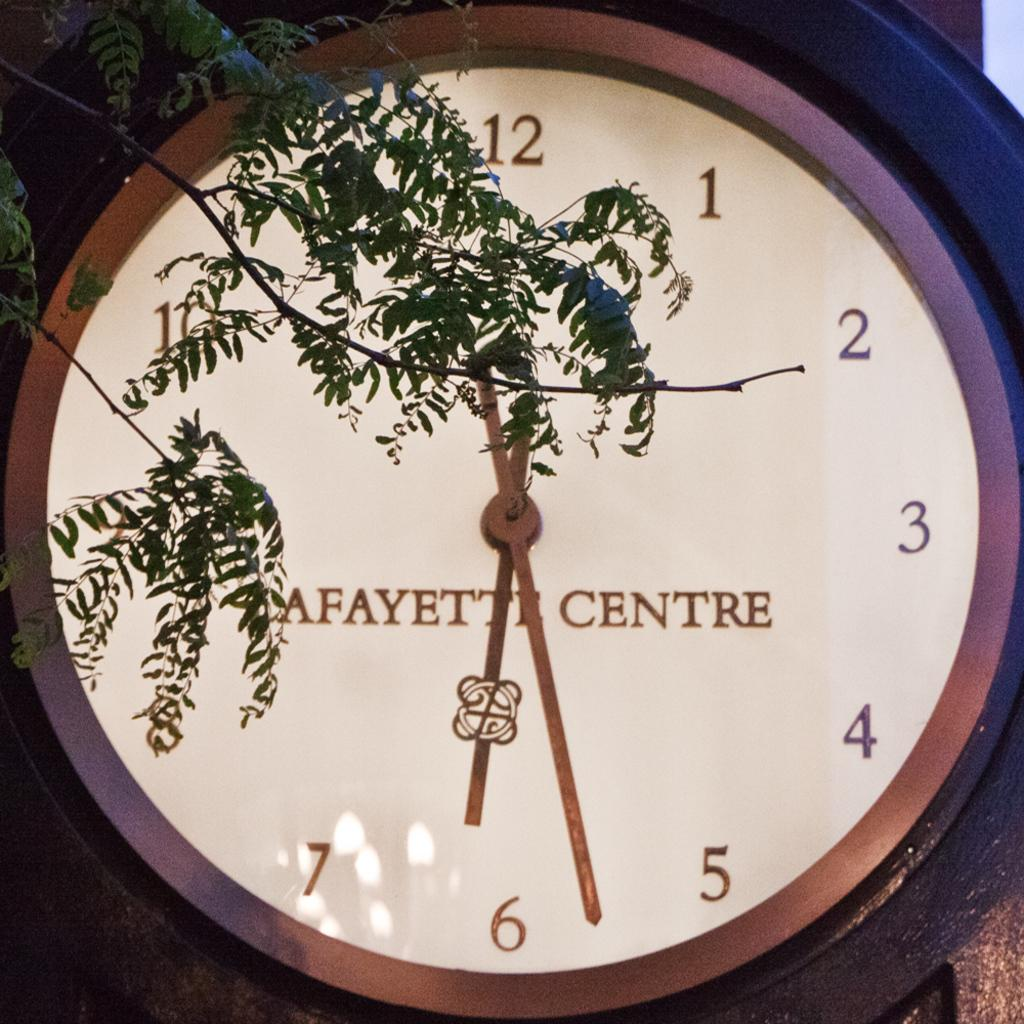<image>
Relay a brief, clear account of the picture shown. a close up a clock reading Lafayette Centre on the face 